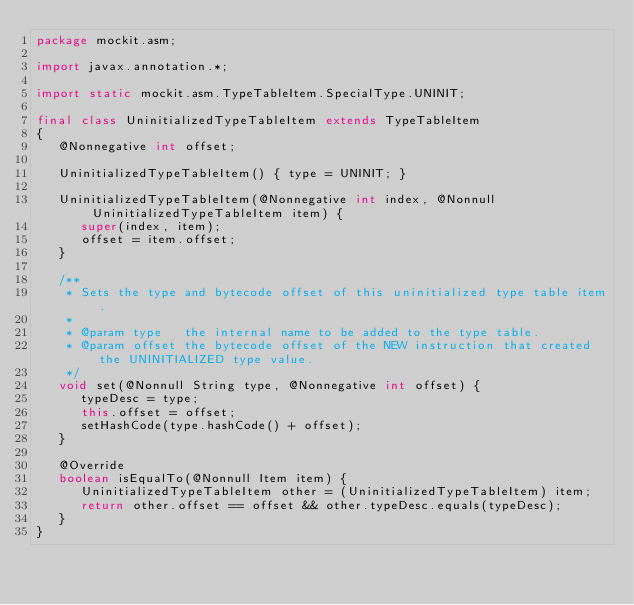Convert code to text. <code><loc_0><loc_0><loc_500><loc_500><_Java_>package mockit.asm;

import javax.annotation.*;

import static mockit.asm.TypeTableItem.SpecialType.UNINIT;

final class UninitializedTypeTableItem extends TypeTableItem
{
   @Nonnegative int offset;

   UninitializedTypeTableItem() { type = UNINIT; }

   UninitializedTypeTableItem(@Nonnegative int index, @Nonnull UninitializedTypeTableItem item) {
      super(index, item);
      offset = item.offset;
   }

   /**
    * Sets the type and bytecode offset of this uninitialized type table item.
    *
    * @param type   the internal name to be added to the type table.
    * @param offset the bytecode offset of the NEW instruction that created the UNINITIALIZED type value.
    */
   void set(@Nonnull String type, @Nonnegative int offset) {
      typeDesc = type;
      this.offset = offset;
      setHashCode(type.hashCode() + offset);
   }

   @Override
   boolean isEqualTo(@Nonnull Item item) {
      UninitializedTypeTableItem other = (UninitializedTypeTableItem) item;
      return other.offset == offset && other.typeDesc.equals(typeDesc);
   }
}
</code> 